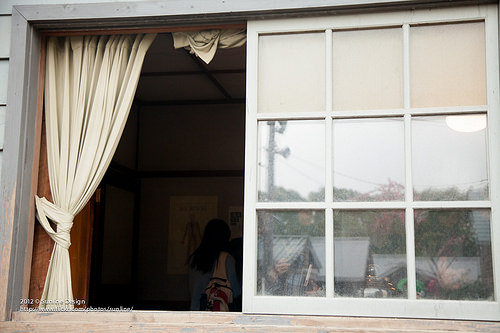<image>
Can you confirm if the girl is next to the house? No. The girl is not positioned next to the house. They are located in different areas of the scene. 